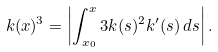Convert formula to latex. <formula><loc_0><loc_0><loc_500><loc_500>k ( x ) ^ { 3 } = \left | \int _ { x _ { 0 } } ^ { x } 3 k ( s ) ^ { 2 } k ^ { \prime } ( s ) \, d s \right | .</formula> 